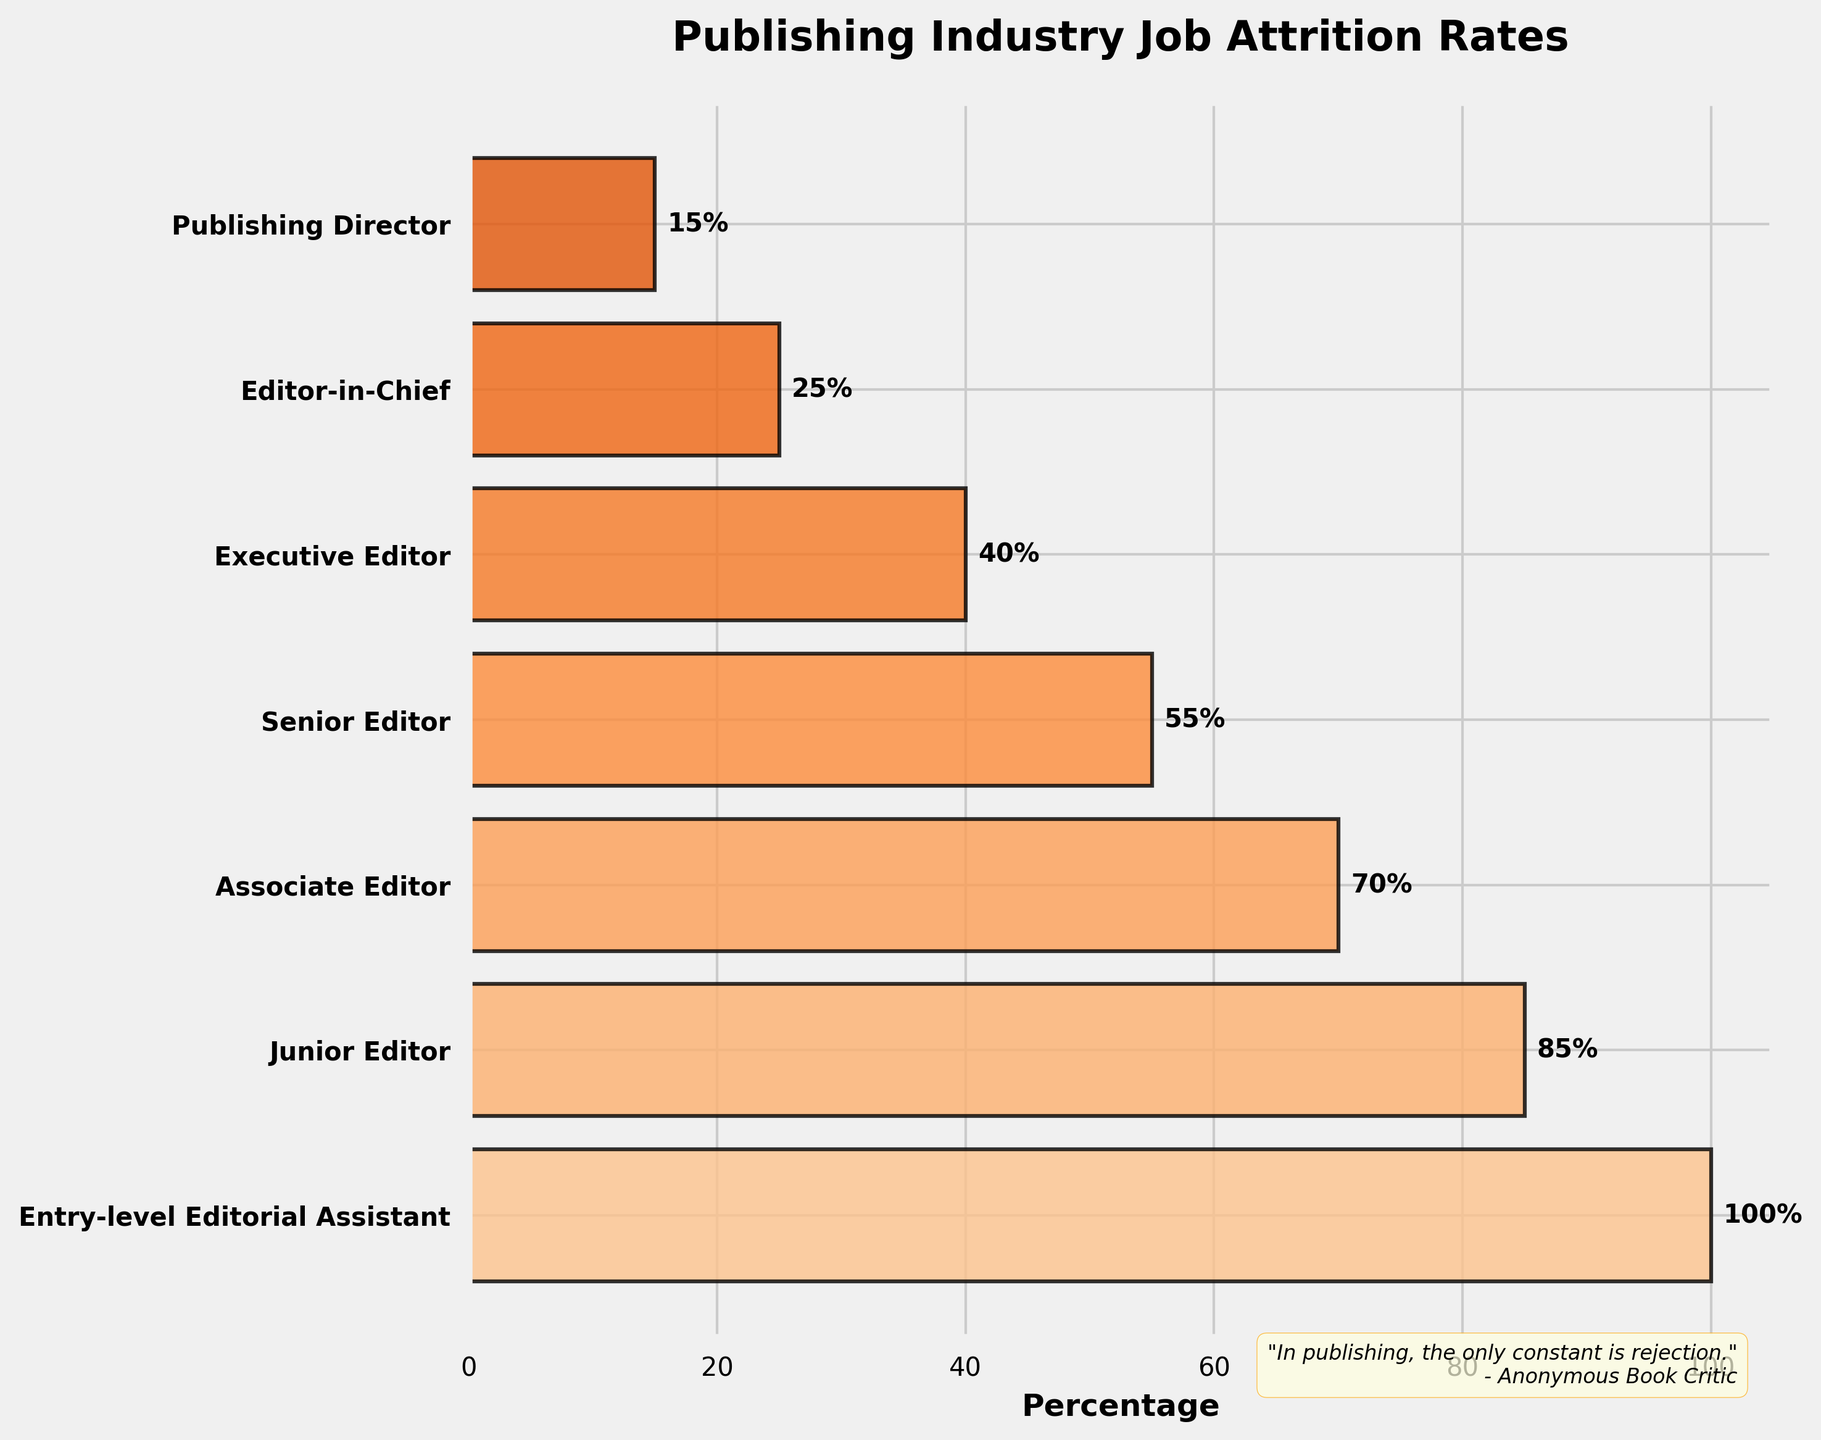1. What is the title of the chart? The title is typically located at the top of the chart. In this case, it reads "Publishing Industry Job Attrition Rates".
Answer: Publishing Industry Job Attrition Rates 2. What is the percentage for Executive Editors? Locate the "Executive Editor" stage on the y-axis, then read the corresponding percentage on the x-axis.
Answer: 40% 3. How many stages are depicted in the funnel chart? Count the distinct labels along the y-axis representing different job stages in the publishing industry. There are 7 stages listed.
Answer: 7 4. Which stage shows the highest attrition rate? The highest attrition rate correlates with the smallest percentage remaining. Identify the stage with the smallest percentage bar.
Answer: Publishing Director 5. How many percentage points drop between the Entry-level Editorial Assistant and Senior Editor? Subtract the percentage of Senior Editor (55%) from that of Entry-level Editorial Assistant (100%).
Answer: 45% 6. What percentage of staff remain from Junior Editor to Associate Editor? Subtract the percentage of Associate Editor (70%) from Junior Editor (85%).
Answer: 15% 7. Compare the attrition rates between the Senior Editor and the Editor-in-Chief. Identify the percentages for both stages and subtract the Editor-in-Chief's percentage (25%) from the Senior Editor's (55%) to get the difference.
Answer: 30% 8. What is the difference in percentage points between the Entry-level Editorial Assistant and the Publishing Director stage? Subtract the percentage of the Publishing Director (15%) from that of Entry-level Editorial Assistant (100%).
Answer: 85% 9. Which job stage has approximately half of the entry-level staff remaining? Identify which stage has a percentage closest to 50% of the Entry-level Editorial Assistant's percentage (100 / 2 = 50). The Senior Editor with 55% is the closest.
Answer: Senior Editor 10. What does the quote at the bottom of the chart say about the publishing industry? The quote is located at the bottom of the chart, generally providing a humorous or reflective insight on the subject.
Answer: "In publishing, the only constant is rejection." 